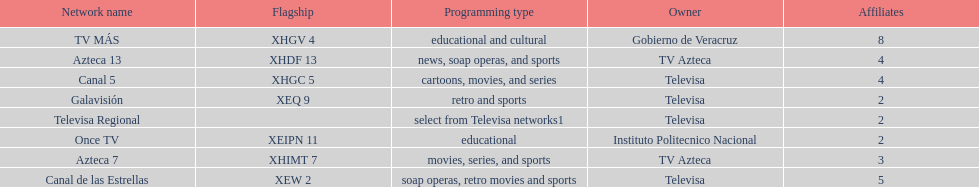How many networks show soap operas? 2. 